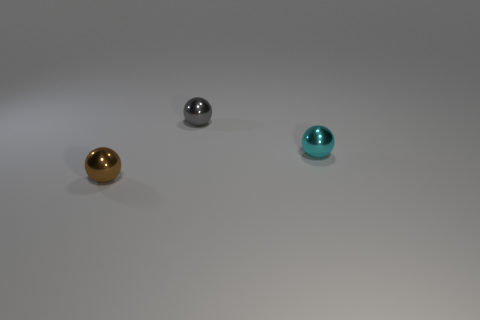What number of other objects are the same shape as the brown metallic object?
Your answer should be very brief. 2. There is a tiny shiny object that is right of the small gray metallic object; is its shape the same as the small shiny object on the left side of the gray shiny thing?
Ensure brevity in your answer.  Yes. There is a tiny object behind the tiny thing that is to the right of the gray metal sphere; what number of small cyan things are to the left of it?
Offer a terse response. 0. What number of other objects are there of the same size as the gray thing?
Offer a terse response. 2. There is a cyan thing that is the same shape as the small gray thing; what is its material?
Offer a terse response. Metal. The tiny object that is on the left side of the tiny thing behind the small shiny object that is right of the tiny gray sphere is made of what material?
Make the answer very short. Metal. The brown thing that is the same material as the gray ball is what size?
Your response must be concise. Small. What is the color of the small metal ball that is behind the small cyan object?
Provide a succinct answer. Gray. There is a thing behind the cyan metallic ball; is it the same size as the small cyan shiny object?
Make the answer very short. Yes. Are there fewer tiny brown shiny spheres than big purple rubber cubes?
Ensure brevity in your answer.  No. 